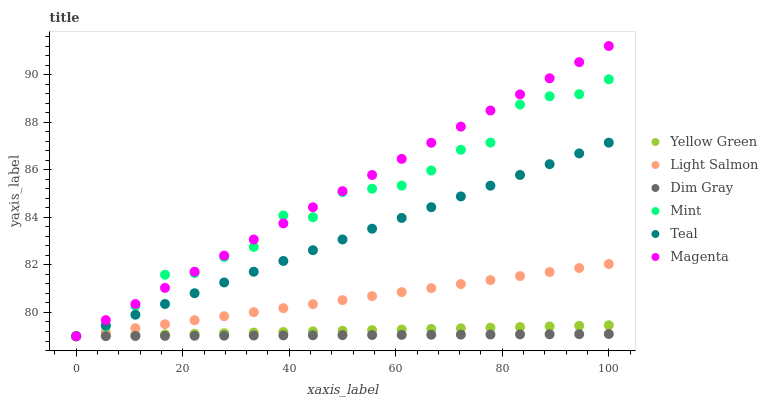Does Dim Gray have the minimum area under the curve?
Answer yes or no. Yes. Does Magenta have the maximum area under the curve?
Answer yes or no. Yes. Does Yellow Green have the minimum area under the curve?
Answer yes or no. No. Does Yellow Green have the maximum area under the curve?
Answer yes or no. No. Is Dim Gray the smoothest?
Answer yes or no. Yes. Is Mint the roughest?
Answer yes or no. Yes. Is Yellow Green the smoothest?
Answer yes or no. No. Is Yellow Green the roughest?
Answer yes or no. No. Does Light Salmon have the lowest value?
Answer yes or no. Yes. Does Magenta have the highest value?
Answer yes or no. Yes. Does Yellow Green have the highest value?
Answer yes or no. No. Does Light Salmon intersect Yellow Green?
Answer yes or no. Yes. Is Light Salmon less than Yellow Green?
Answer yes or no. No. Is Light Salmon greater than Yellow Green?
Answer yes or no. No. 